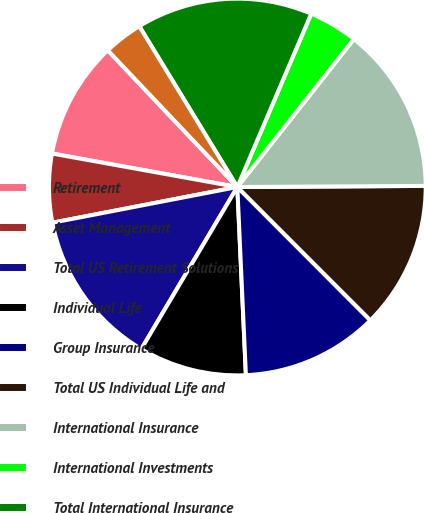Convert chart. <chart><loc_0><loc_0><loc_500><loc_500><pie_chart><fcel>Retirement<fcel>Asset Management<fcel>Total US Retirement Solutions<fcel>Individual Life<fcel>Group Insurance<fcel>Total US Individual Life and<fcel>International Insurance<fcel>International Investments<fcel>Total International Insurance<fcel>Corporate Operations<nl><fcel>10.08%<fcel>5.88%<fcel>13.45%<fcel>9.24%<fcel>11.76%<fcel>12.61%<fcel>14.29%<fcel>4.2%<fcel>15.13%<fcel>3.36%<nl></chart> 